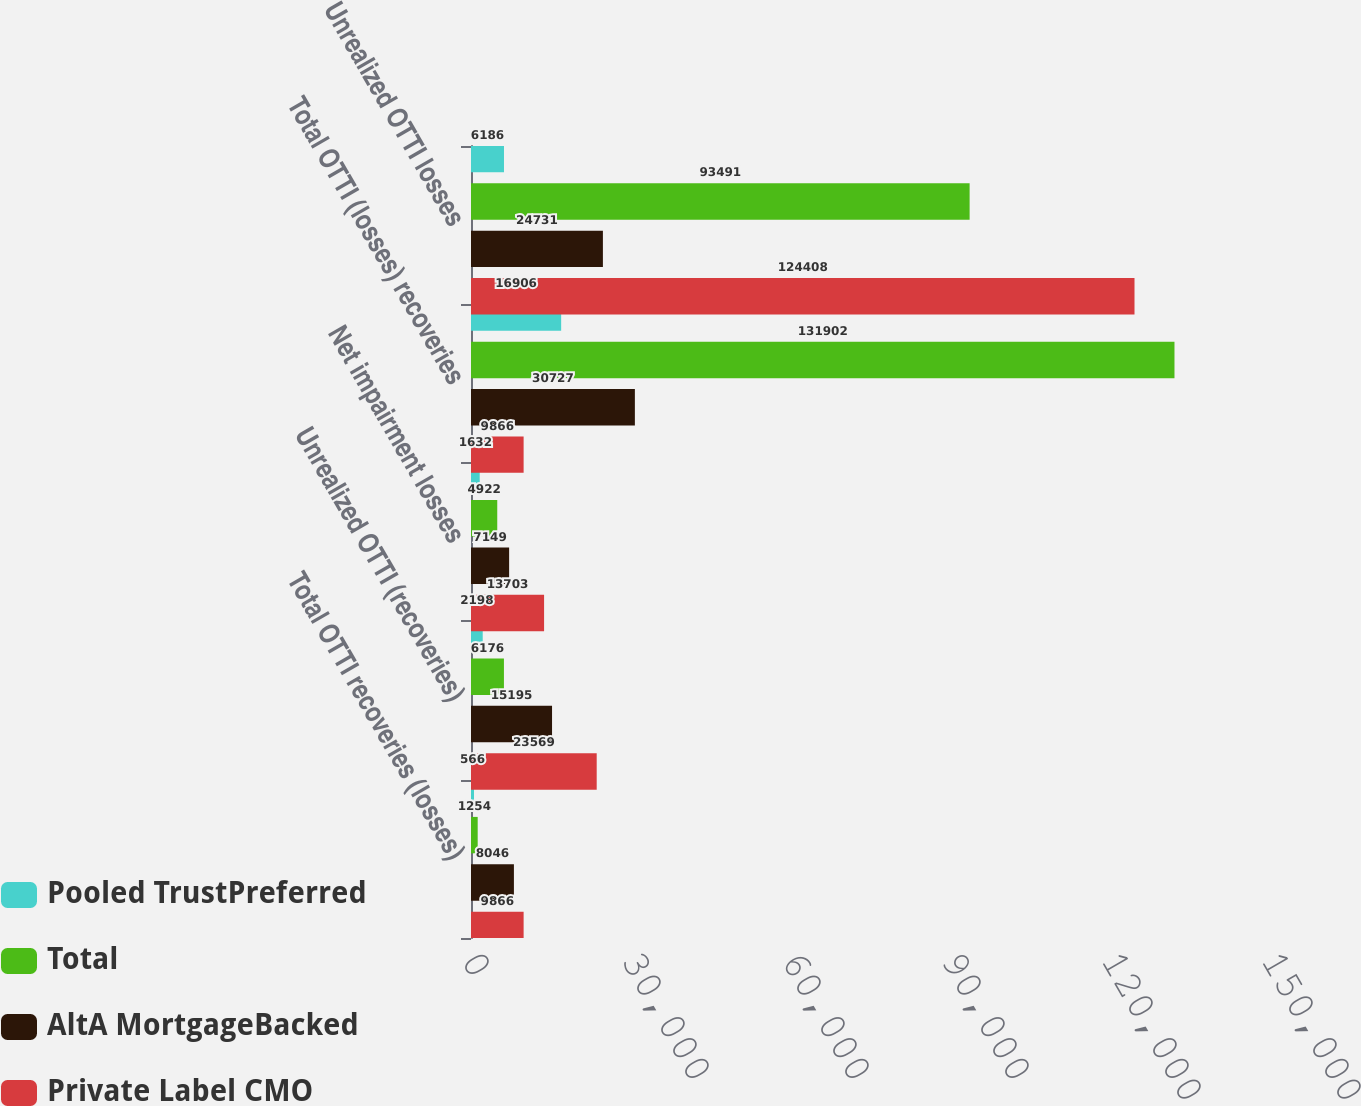Convert chart to OTSL. <chart><loc_0><loc_0><loc_500><loc_500><stacked_bar_chart><ecel><fcel>Total OTTI recoveries (losses)<fcel>Unrealized OTTI (recoveries)<fcel>Net impairment losses<fcel>Total OTTI (losses) recoveries<fcel>Unrealized OTTI losses<nl><fcel>Pooled TrustPreferred<fcel>566<fcel>2198<fcel>1632<fcel>16906<fcel>6186<nl><fcel>Total<fcel>1254<fcel>6176<fcel>4922<fcel>131902<fcel>93491<nl><fcel>AltA MortgageBacked<fcel>8046<fcel>15195<fcel>7149<fcel>30727<fcel>24731<nl><fcel>Private Label CMO<fcel>9866<fcel>23569<fcel>13703<fcel>9866<fcel>124408<nl></chart> 